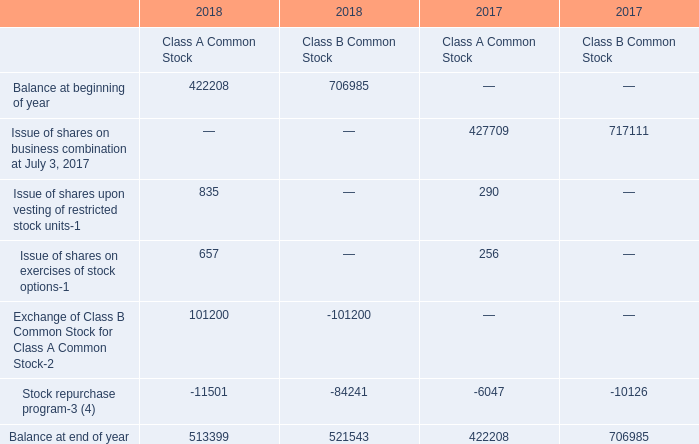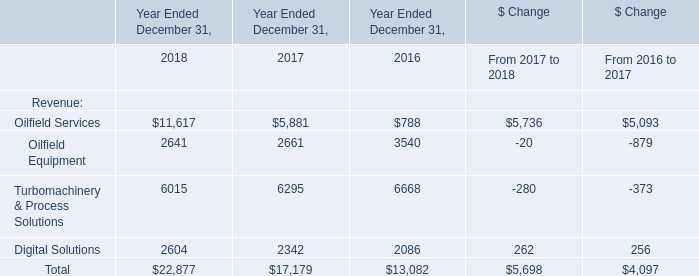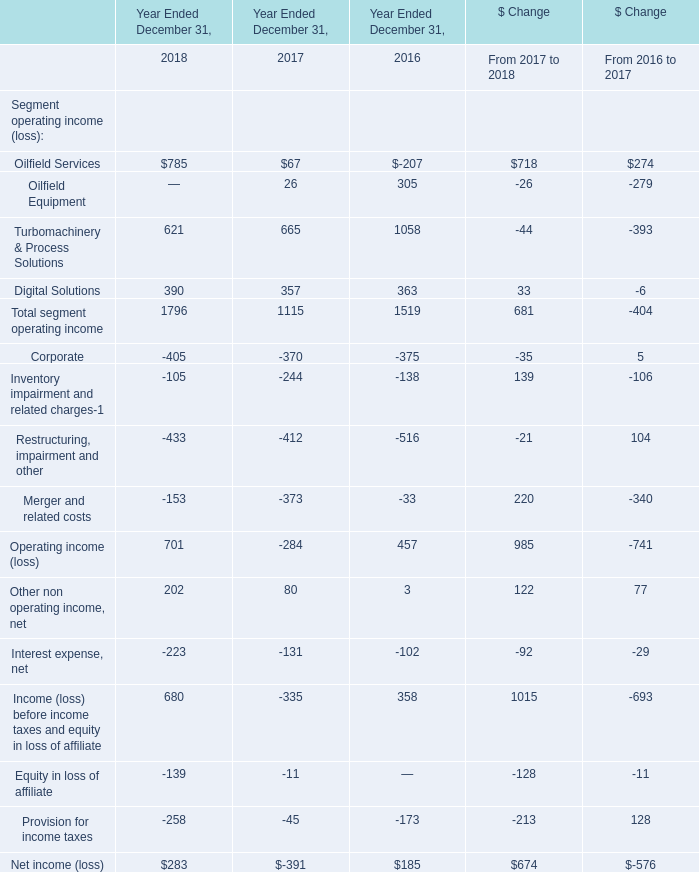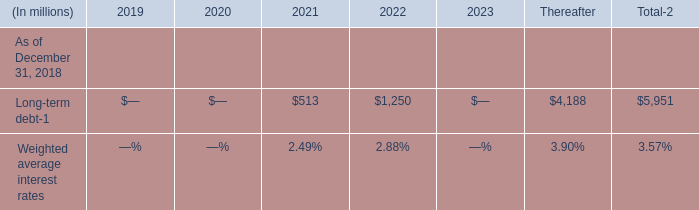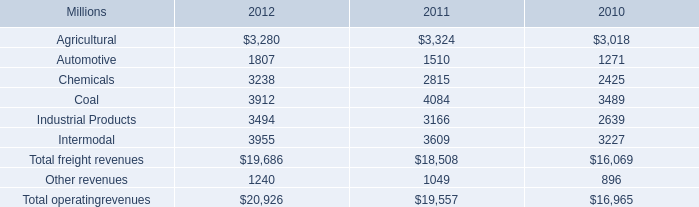What is the sum of Digital Solutions of Year Ended December 31, 2018, and Stock repurchase program of 2017 Class A Common Stock ? 
Computations: (2604.0 + 6047.0)
Answer: 8651.0. 